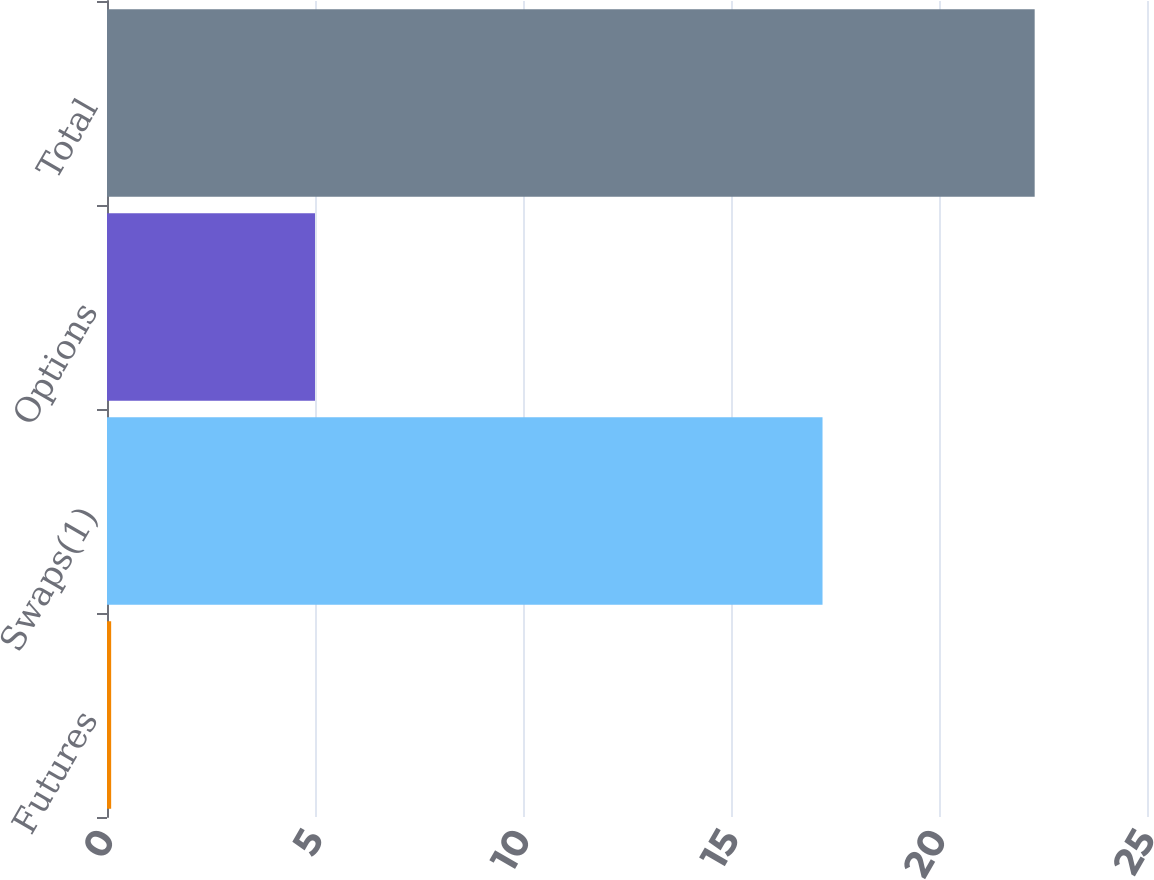Convert chart to OTSL. <chart><loc_0><loc_0><loc_500><loc_500><bar_chart><fcel>Futures<fcel>Swaps(1)<fcel>Options<fcel>Total<nl><fcel>0.1<fcel>17.2<fcel>5<fcel>22.3<nl></chart> 